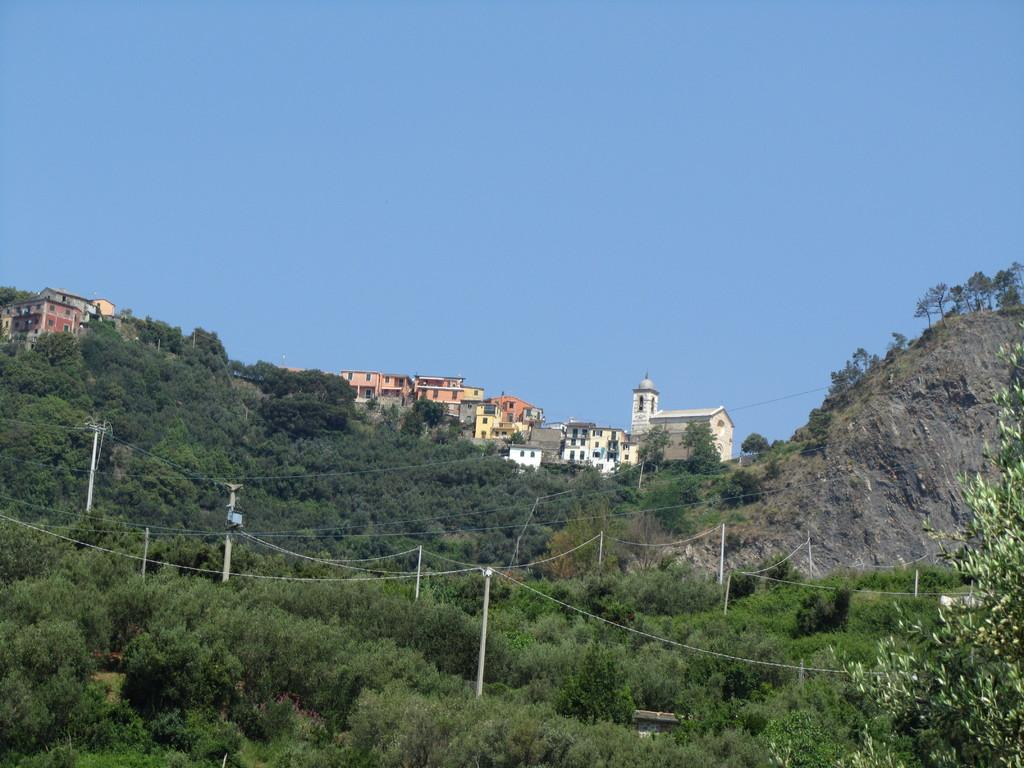What type of natural elements can be seen in the image? There are trees in the image. What man-made structures are present in the image? There are poles, wires, a mountain, buildings, and the sky is blue in color. Can you describe the sky in the image? The sky is blue in color. What are the babies teaching in the image? There are no babies or teaching activities present in the image. 